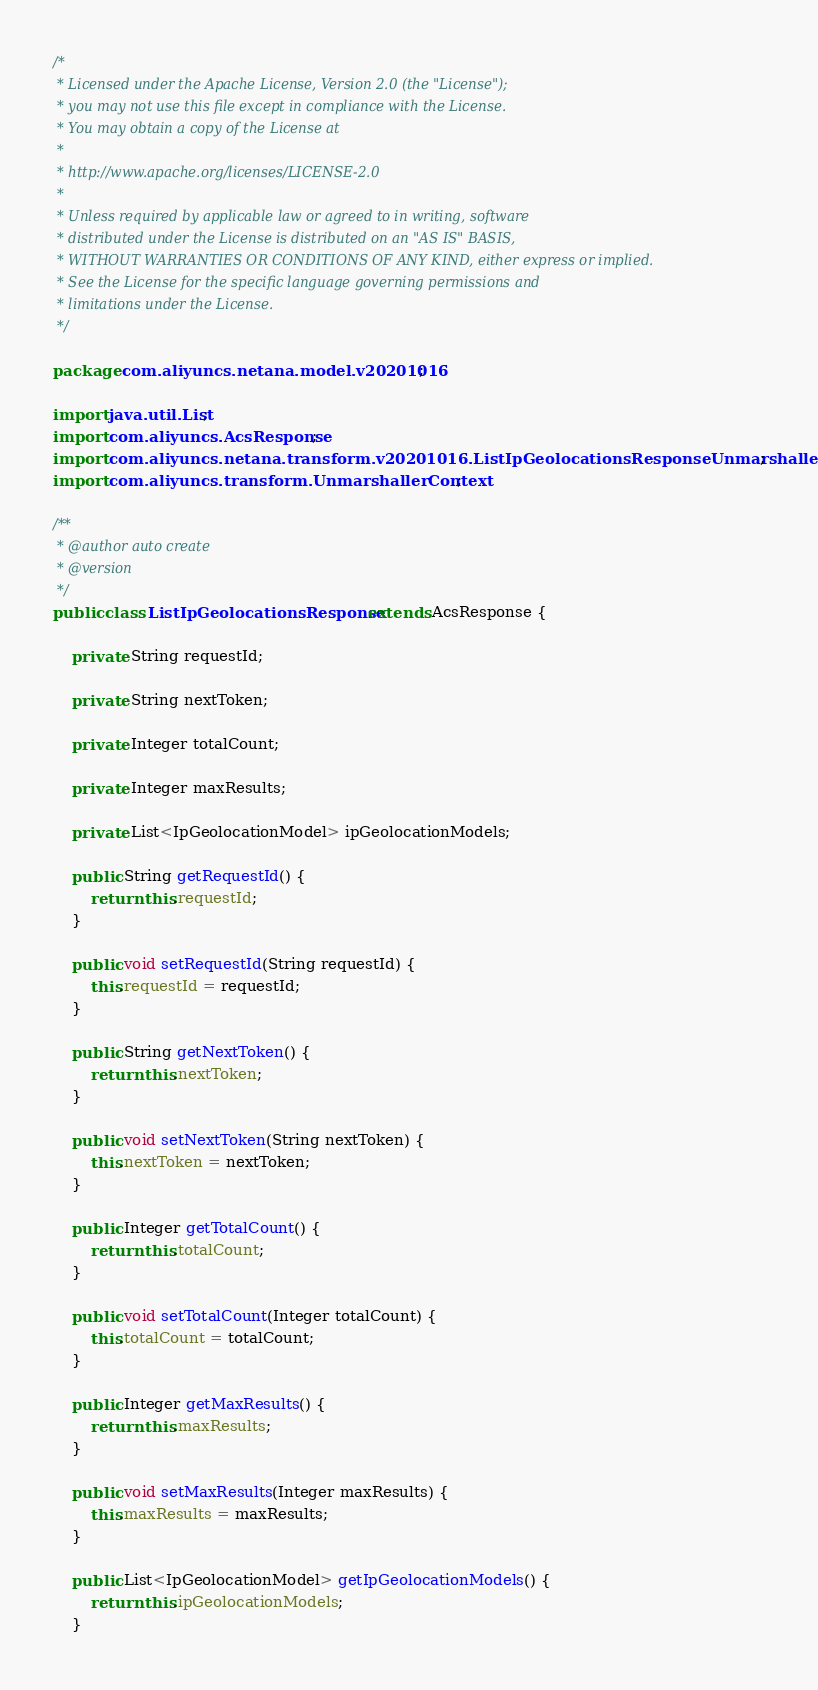<code> <loc_0><loc_0><loc_500><loc_500><_Java_>/*
 * Licensed under the Apache License, Version 2.0 (the "License");
 * you may not use this file except in compliance with the License.
 * You may obtain a copy of the License at
 *
 * http://www.apache.org/licenses/LICENSE-2.0
 *
 * Unless required by applicable law or agreed to in writing, software
 * distributed under the License is distributed on an "AS IS" BASIS,
 * WITHOUT WARRANTIES OR CONDITIONS OF ANY KIND, either express or implied.
 * See the License for the specific language governing permissions and
 * limitations under the License.
 */

package com.aliyuncs.netana.model.v20201016;

import java.util.List;
import com.aliyuncs.AcsResponse;
import com.aliyuncs.netana.transform.v20201016.ListIpGeolocationsResponseUnmarshaller;
import com.aliyuncs.transform.UnmarshallerContext;

/**
 * @author auto create
 * @version 
 */
public class ListIpGeolocationsResponse extends AcsResponse {

	private String requestId;

	private String nextToken;

	private Integer totalCount;

	private Integer maxResults;

	private List<IpGeolocationModel> ipGeolocationModels;

	public String getRequestId() {
		return this.requestId;
	}

	public void setRequestId(String requestId) {
		this.requestId = requestId;
	}

	public String getNextToken() {
		return this.nextToken;
	}

	public void setNextToken(String nextToken) {
		this.nextToken = nextToken;
	}

	public Integer getTotalCount() {
		return this.totalCount;
	}

	public void setTotalCount(Integer totalCount) {
		this.totalCount = totalCount;
	}

	public Integer getMaxResults() {
		return this.maxResults;
	}

	public void setMaxResults(Integer maxResults) {
		this.maxResults = maxResults;
	}

	public List<IpGeolocationModel> getIpGeolocationModels() {
		return this.ipGeolocationModels;
	}
</code> 